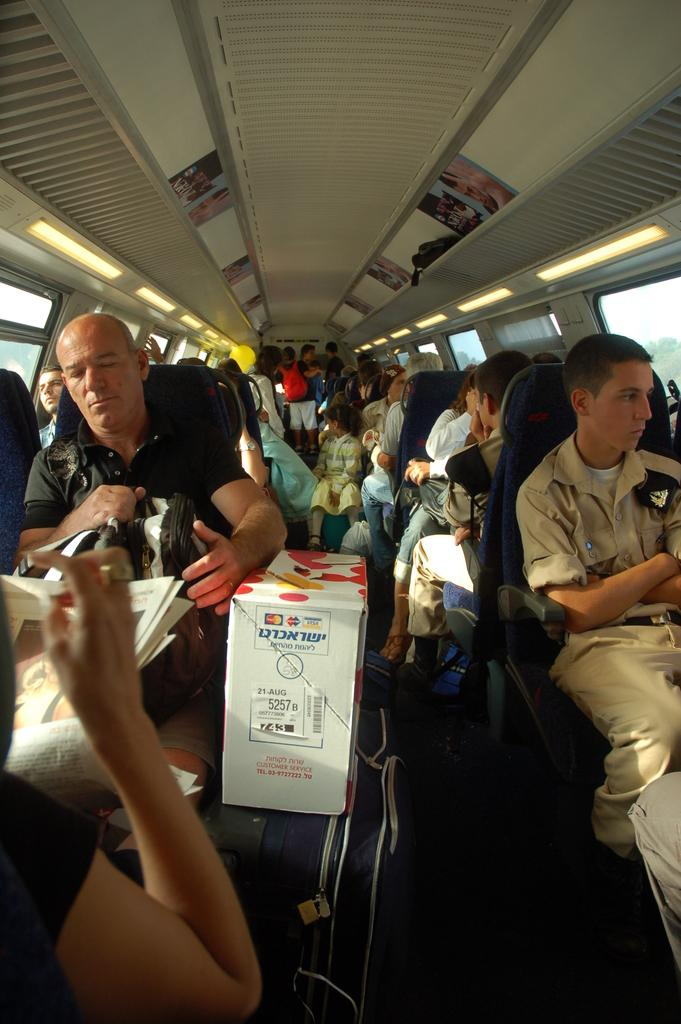What are the people in the image doing? The people in the image are sitting on chairs. How are the chairs arranged in the image? The chairs are arranged in series on both the right and left sides of the image, resembling a bus. What type of cake can be seen on the chairs in the image? There is no cake present on the chairs in the image; it features people sitting on chairs arranged like a bus. What type of animal is sitting on the chairs with the people in the image? There are no animals present on the chairs with the people in the image; it only features people sitting on chairs. 